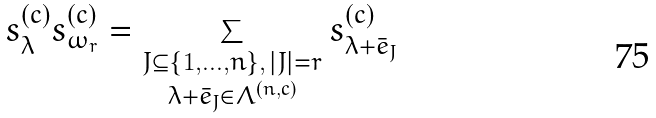Convert formula to latex. <formula><loc_0><loc_0><loc_500><loc_500>s _ { \lambda } ^ { ( c ) } s _ { \omega _ { r } } ^ { ( c ) } = \sum _ { \substack { J \subseteq \{ 1 , \dots , n \} , \, | J | = r \\ \lambda + \bar { e } _ { J } \in \Lambda ^ { ( n , c ) } } } s _ { \lambda + \bar { e } _ { J } } ^ { ( c ) }</formula> 